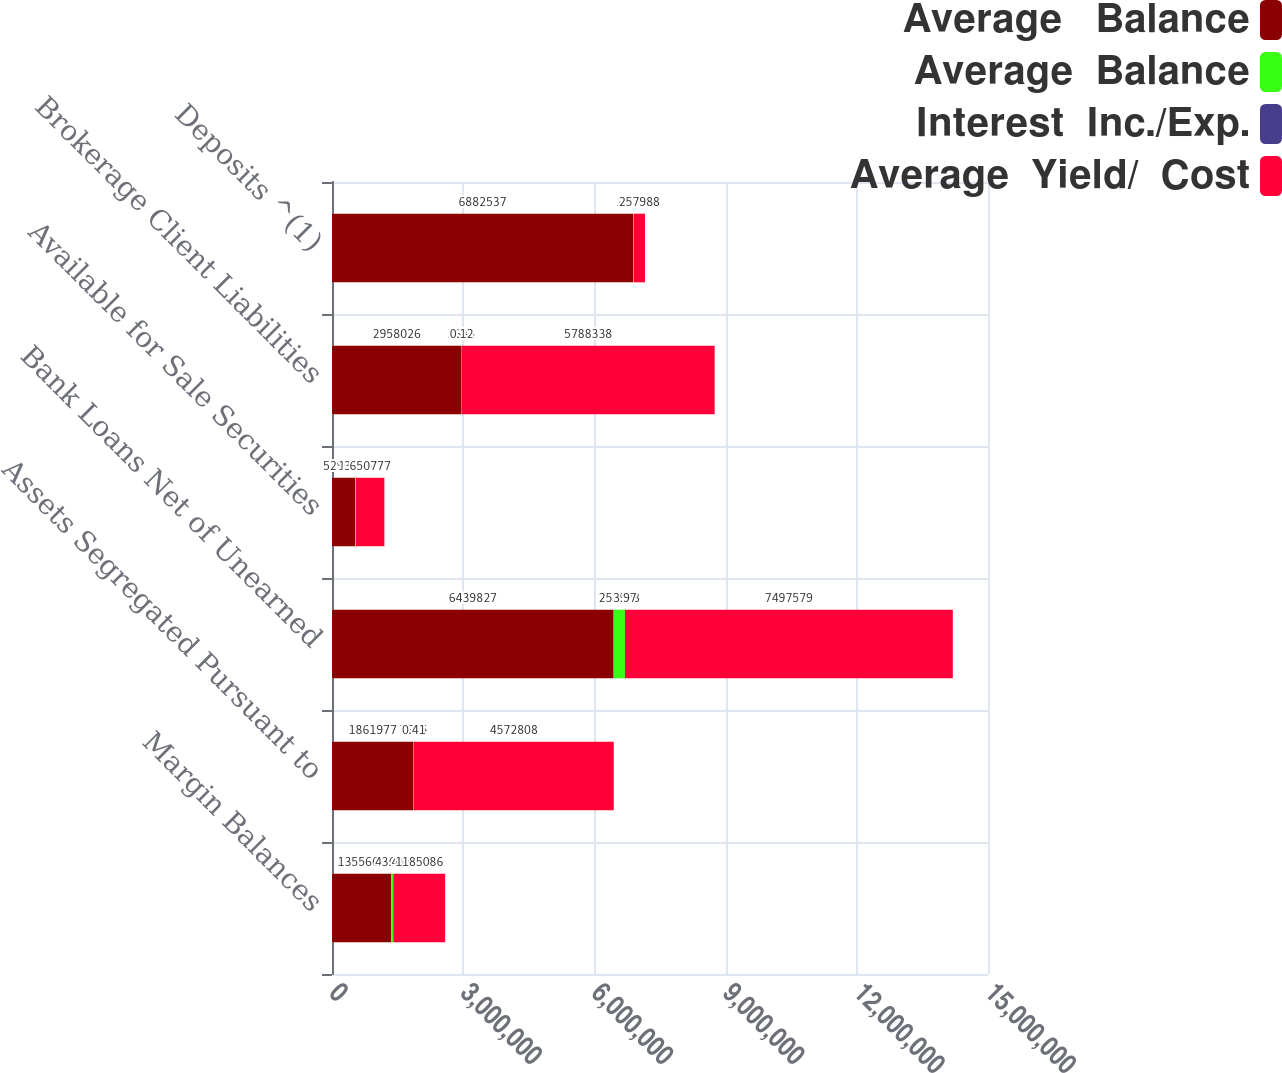<chart> <loc_0><loc_0><loc_500><loc_500><stacked_bar_chart><ecel><fcel>Margin Balances<fcel>Assets Segregated Pursuant to<fcel>Bank Loans Net of Unearned<fcel>Available for Sale Securities<fcel>Brokerage Client Liabilities<fcel>Deposits ^(1)<nl><fcel>Average   Balance<fcel>1.35566e+06<fcel>1.86198e+06<fcel>6.43983e+06<fcel>529056<fcel>2.95803e+06<fcel>6.88254e+06<nl><fcel>Average  Balance<fcel>46650<fcel>7685<fcel>257988<fcel>17846<fcel>3688<fcel>16053<nl><fcel>Interest  Inc./Exp.<fcel>3.44<fcel>0.41<fcel>3.97<fcel>3.37<fcel>0.12<fcel>0.23<nl><fcel>Average  Yield/  Cost<fcel>1.18509e+06<fcel>4.57281e+06<fcel>7.49758e+06<fcel>650777<fcel>5.78834e+06<fcel>257988<nl></chart> 